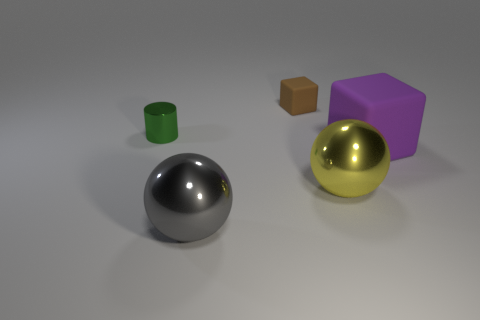Add 5 big metallic things. How many objects exist? 10 Subtract all blocks. How many objects are left? 3 Subtract all tiny brown cubes. Subtract all yellow objects. How many objects are left? 3 Add 3 metal things. How many metal things are left? 6 Add 1 green rubber blocks. How many green rubber blocks exist? 1 Subtract 1 green cylinders. How many objects are left? 4 